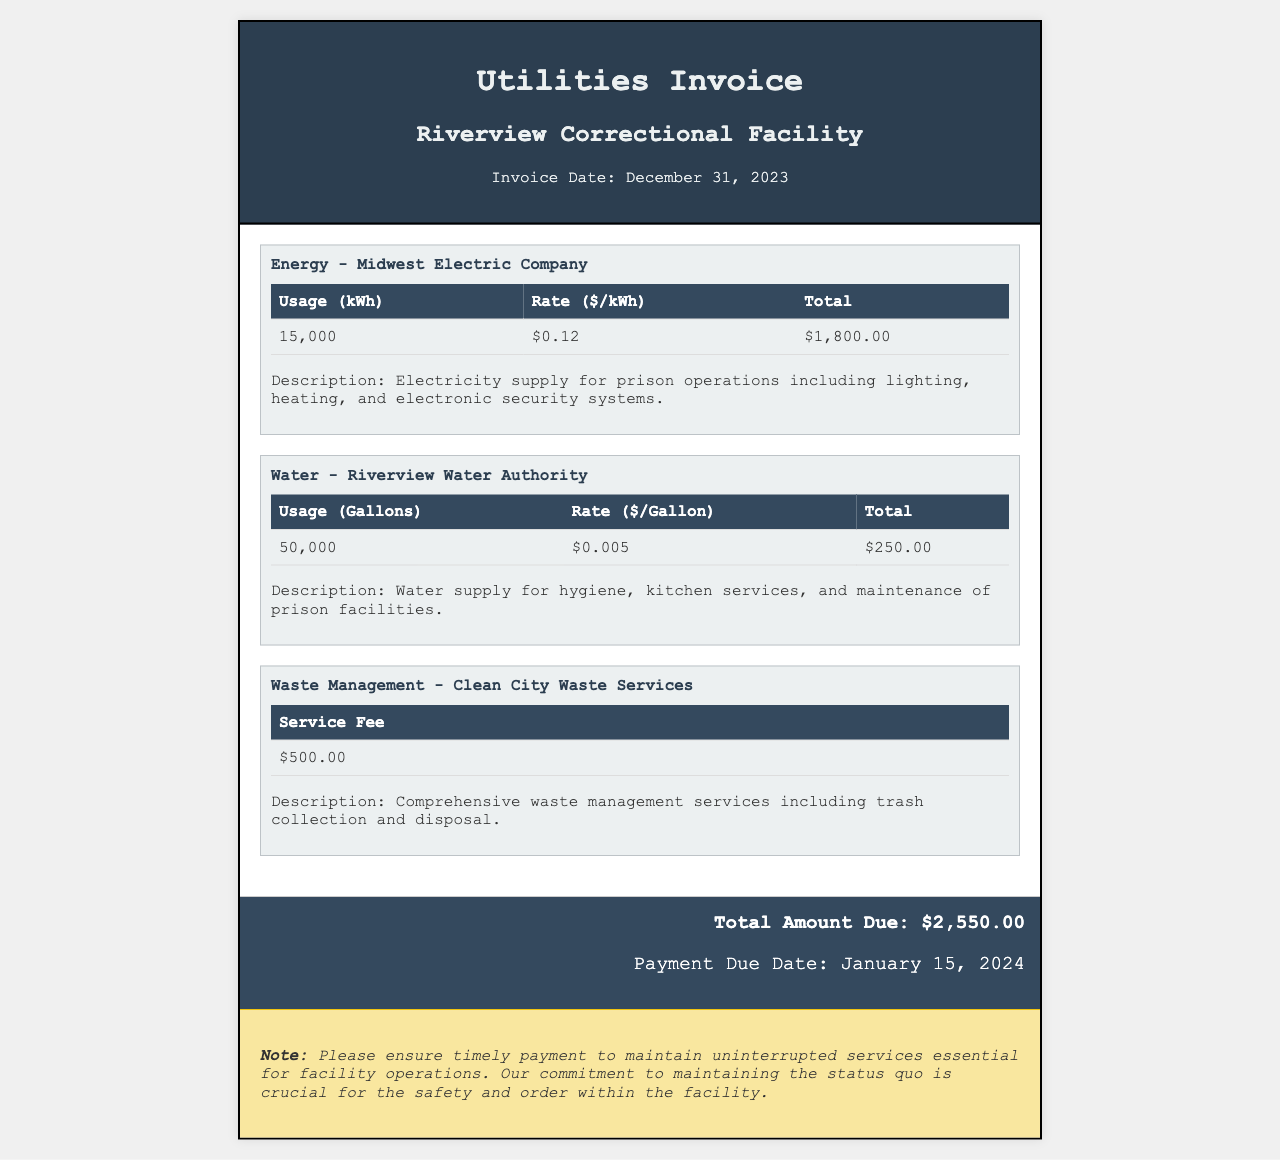What is the total amount due? The total amount due is presented in the total section of the invoice.
Answer: $2,550.00 What is the service fee for waste management? The service fee for waste management is listed in the waste management section of the invoice.
Answer: $500.00 What is the usage for electricity? The usage for electricity is specified in the energy section of the invoice.
Answer: 15,000 kWh Who is the water service provider? The water service provider is mentioned in the water section of the invoice.
Answer: Riverview Water Authority What is the payment due date? The payment due date is indicated in the total section of the invoice.
Answer: January 15, 2024 How many gallons of water were used? The number of gallons of water used is provided in the water section of the invoice.
Answer: 50,000 What is the rate per kWh for electricity? The rate per kWh for electricity is detailed in the energy section of the invoice.
Answer: $0.12 What kind of services are included in the waste management fee? The type of services related to the waste management fee is described in the waste management section of the invoice.
Answer: Comprehensive waste management services What description is given for the water supply? The description for the water supply is included in the water section of the invoice.
Answer: Water supply for hygiene, kitchen services, and maintenance of prison facilities 